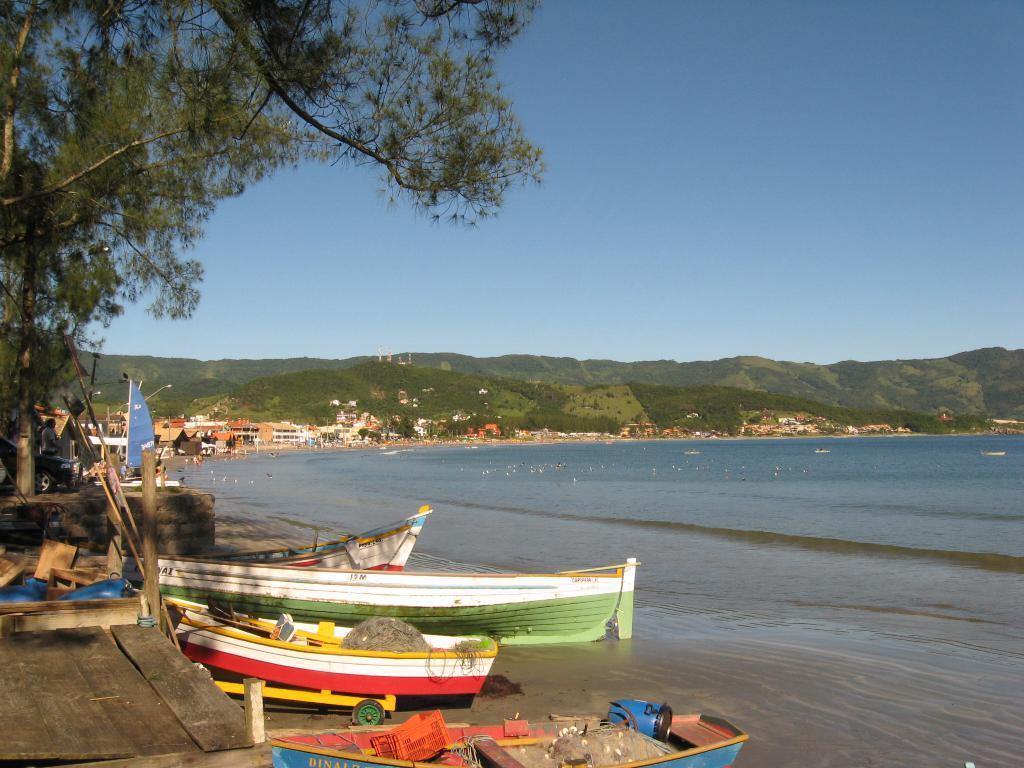In one or two sentences, can you explain what this image depicts? In the image, it is a sea shore and there are some boats beside the sea and in the left side there is a big tree and behind the sea there are many houses and mountains. 